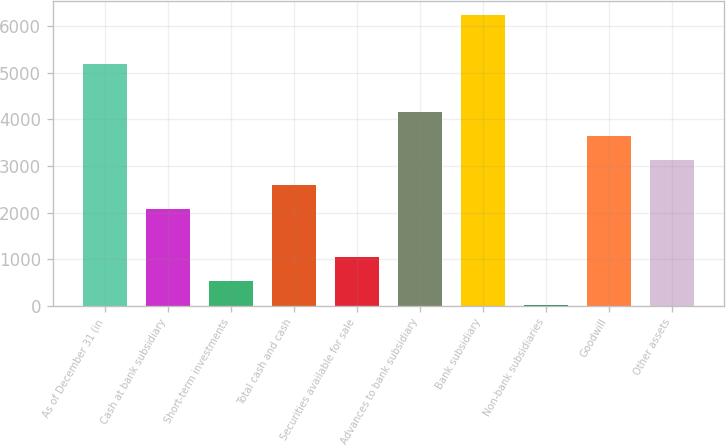Convert chart. <chart><loc_0><loc_0><loc_500><loc_500><bar_chart><fcel>As of December 31 (in<fcel>Cash at bank subsidiary<fcel>Short-term investments<fcel>Total cash and cash<fcel>Securities available for sale<fcel>Advances to bank subsidiary<fcel>Bank subsidiary<fcel>Non-bank subsidiaries<fcel>Goodwill<fcel>Other assets<nl><fcel>5201.3<fcel>2081.42<fcel>521.48<fcel>2601.4<fcel>1041.46<fcel>4161.34<fcel>6241.26<fcel>1.5<fcel>3641.36<fcel>3121.38<nl></chart> 